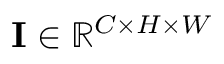Convert formula to latex. <formula><loc_0><loc_0><loc_500><loc_500>I \in \mathbb { R } ^ { C \times H \times W }</formula> 